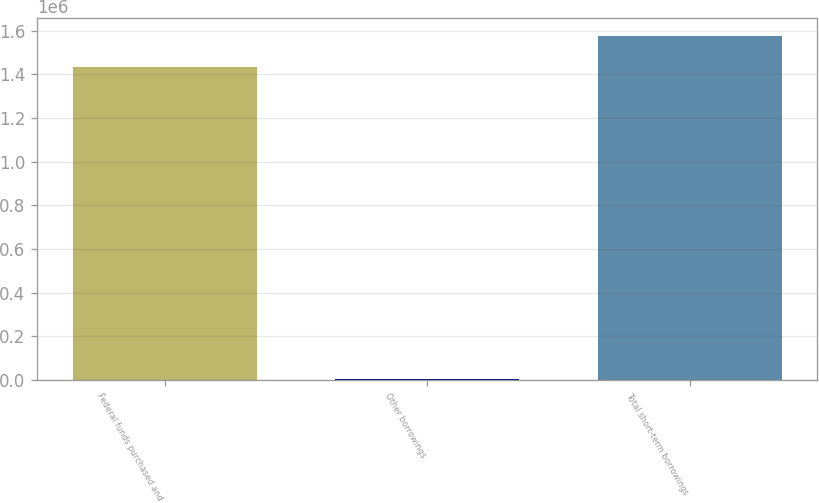Convert chart. <chart><loc_0><loc_0><loc_500><loc_500><bar_chart><fcel>Federal funds purchased and<fcel>Other borrowings<fcel>Total short-term borrowings<nl><fcel>1.43431e+06<fcel>6782<fcel>1.57774e+06<nl></chart> 